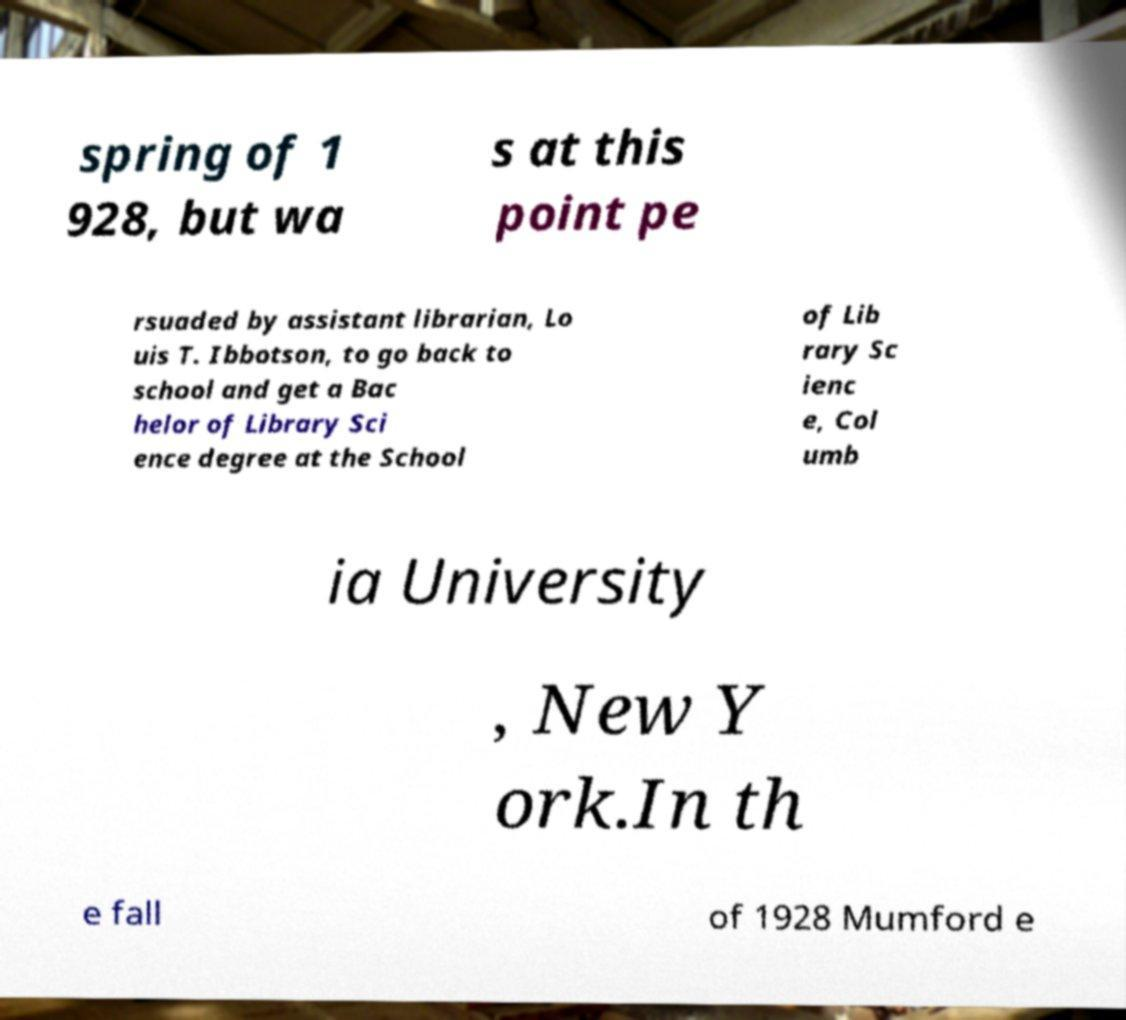For documentation purposes, I need the text within this image transcribed. Could you provide that? spring of 1 928, but wa s at this point pe rsuaded by assistant librarian, Lo uis T. Ibbotson, to go back to school and get a Bac helor of Library Sci ence degree at the School of Lib rary Sc ienc e, Col umb ia University , New Y ork.In th e fall of 1928 Mumford e 